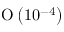<formula> <loc_0><loc_0><loc_500><loc_500>O \left ( 1 0 ^ { - 4 } \right )</formula> 